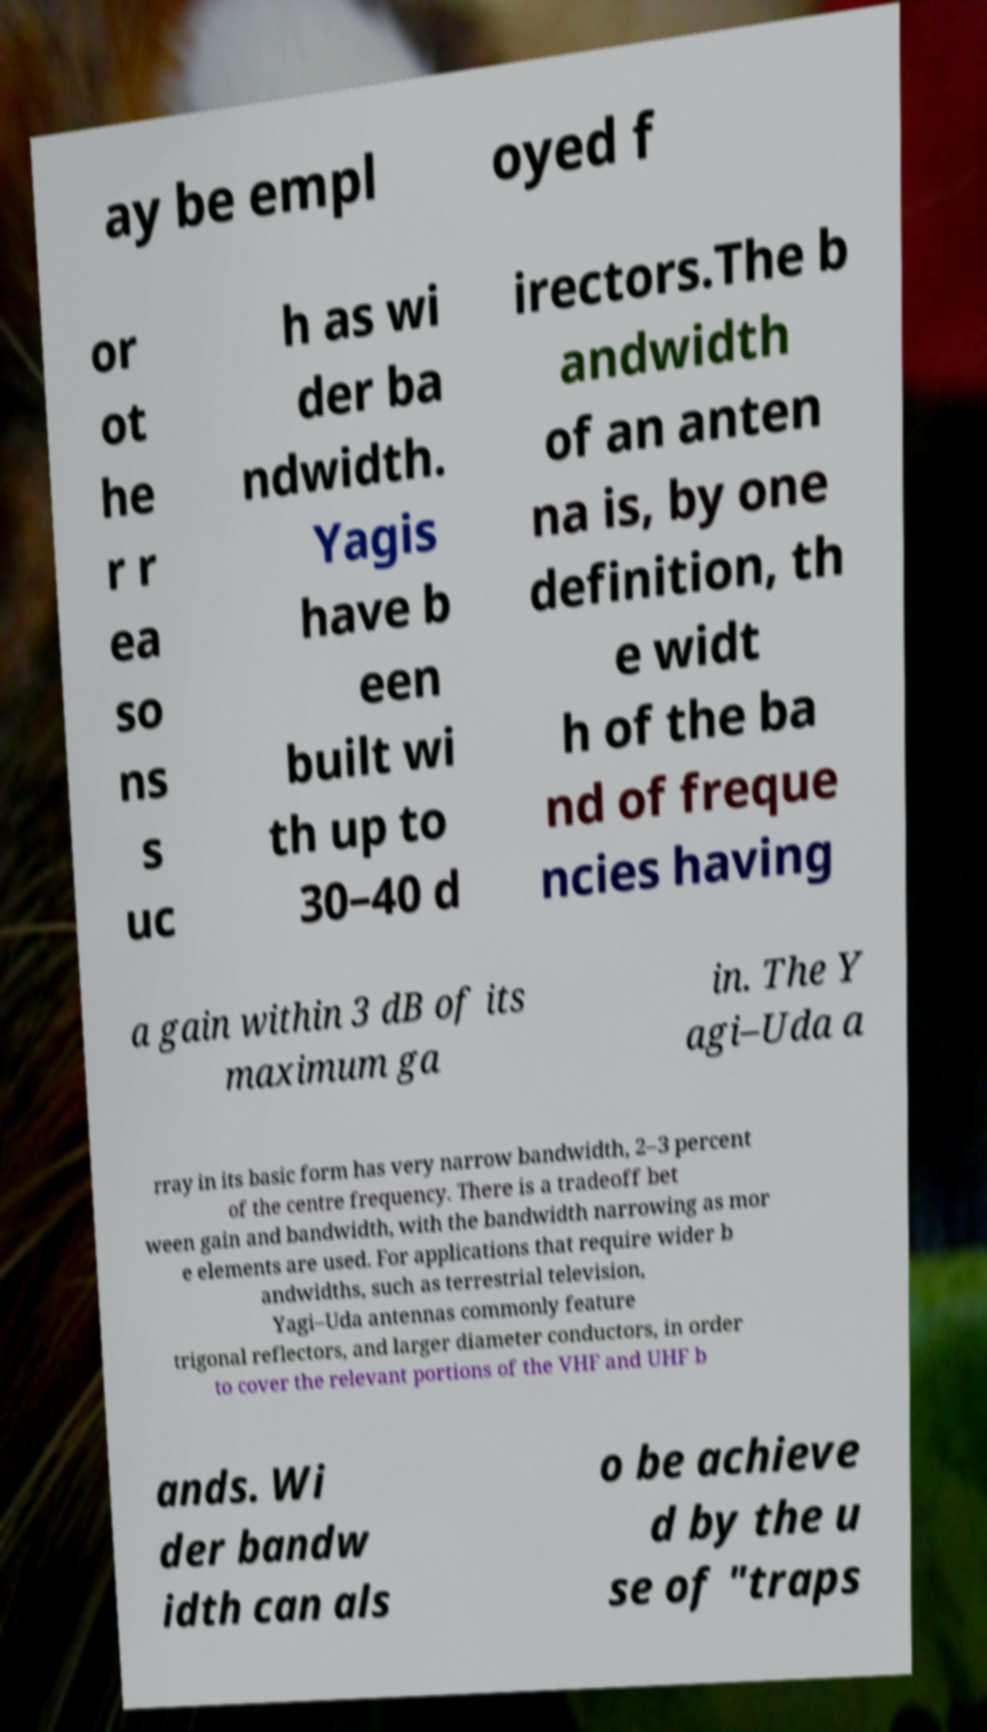Could you assist in decoding the text presented in this image and type it out clearly? ay be empl oyed f or ot he r r ea so ns s uc h as wi der ba ndwidth. Yagis have b een built wi th up to 30–40 d irectors.The b andwidth of an anten na is, by one definition, th e widt h of the ba nd of freque ncies having a gain within 3 dB of its maximum ga in. The Y agi–Uda a rray in its basic form has very narrow bandwidth, 2–3 percent of the centre frequency. There is a tradeoff bet ween gain and bandwidth, with the bandwidth narrowing as mor e elements are used. For applications that require wider b andwidths, such as terrestrial television, Yagi–Uda antennas commonly feature trigonal reflectors, and larger diameter conductors, in order to cover the relevant portions of the VHF and UHF b ands. Wi der bandw idth can als o be achieve d by the u se of "traps 